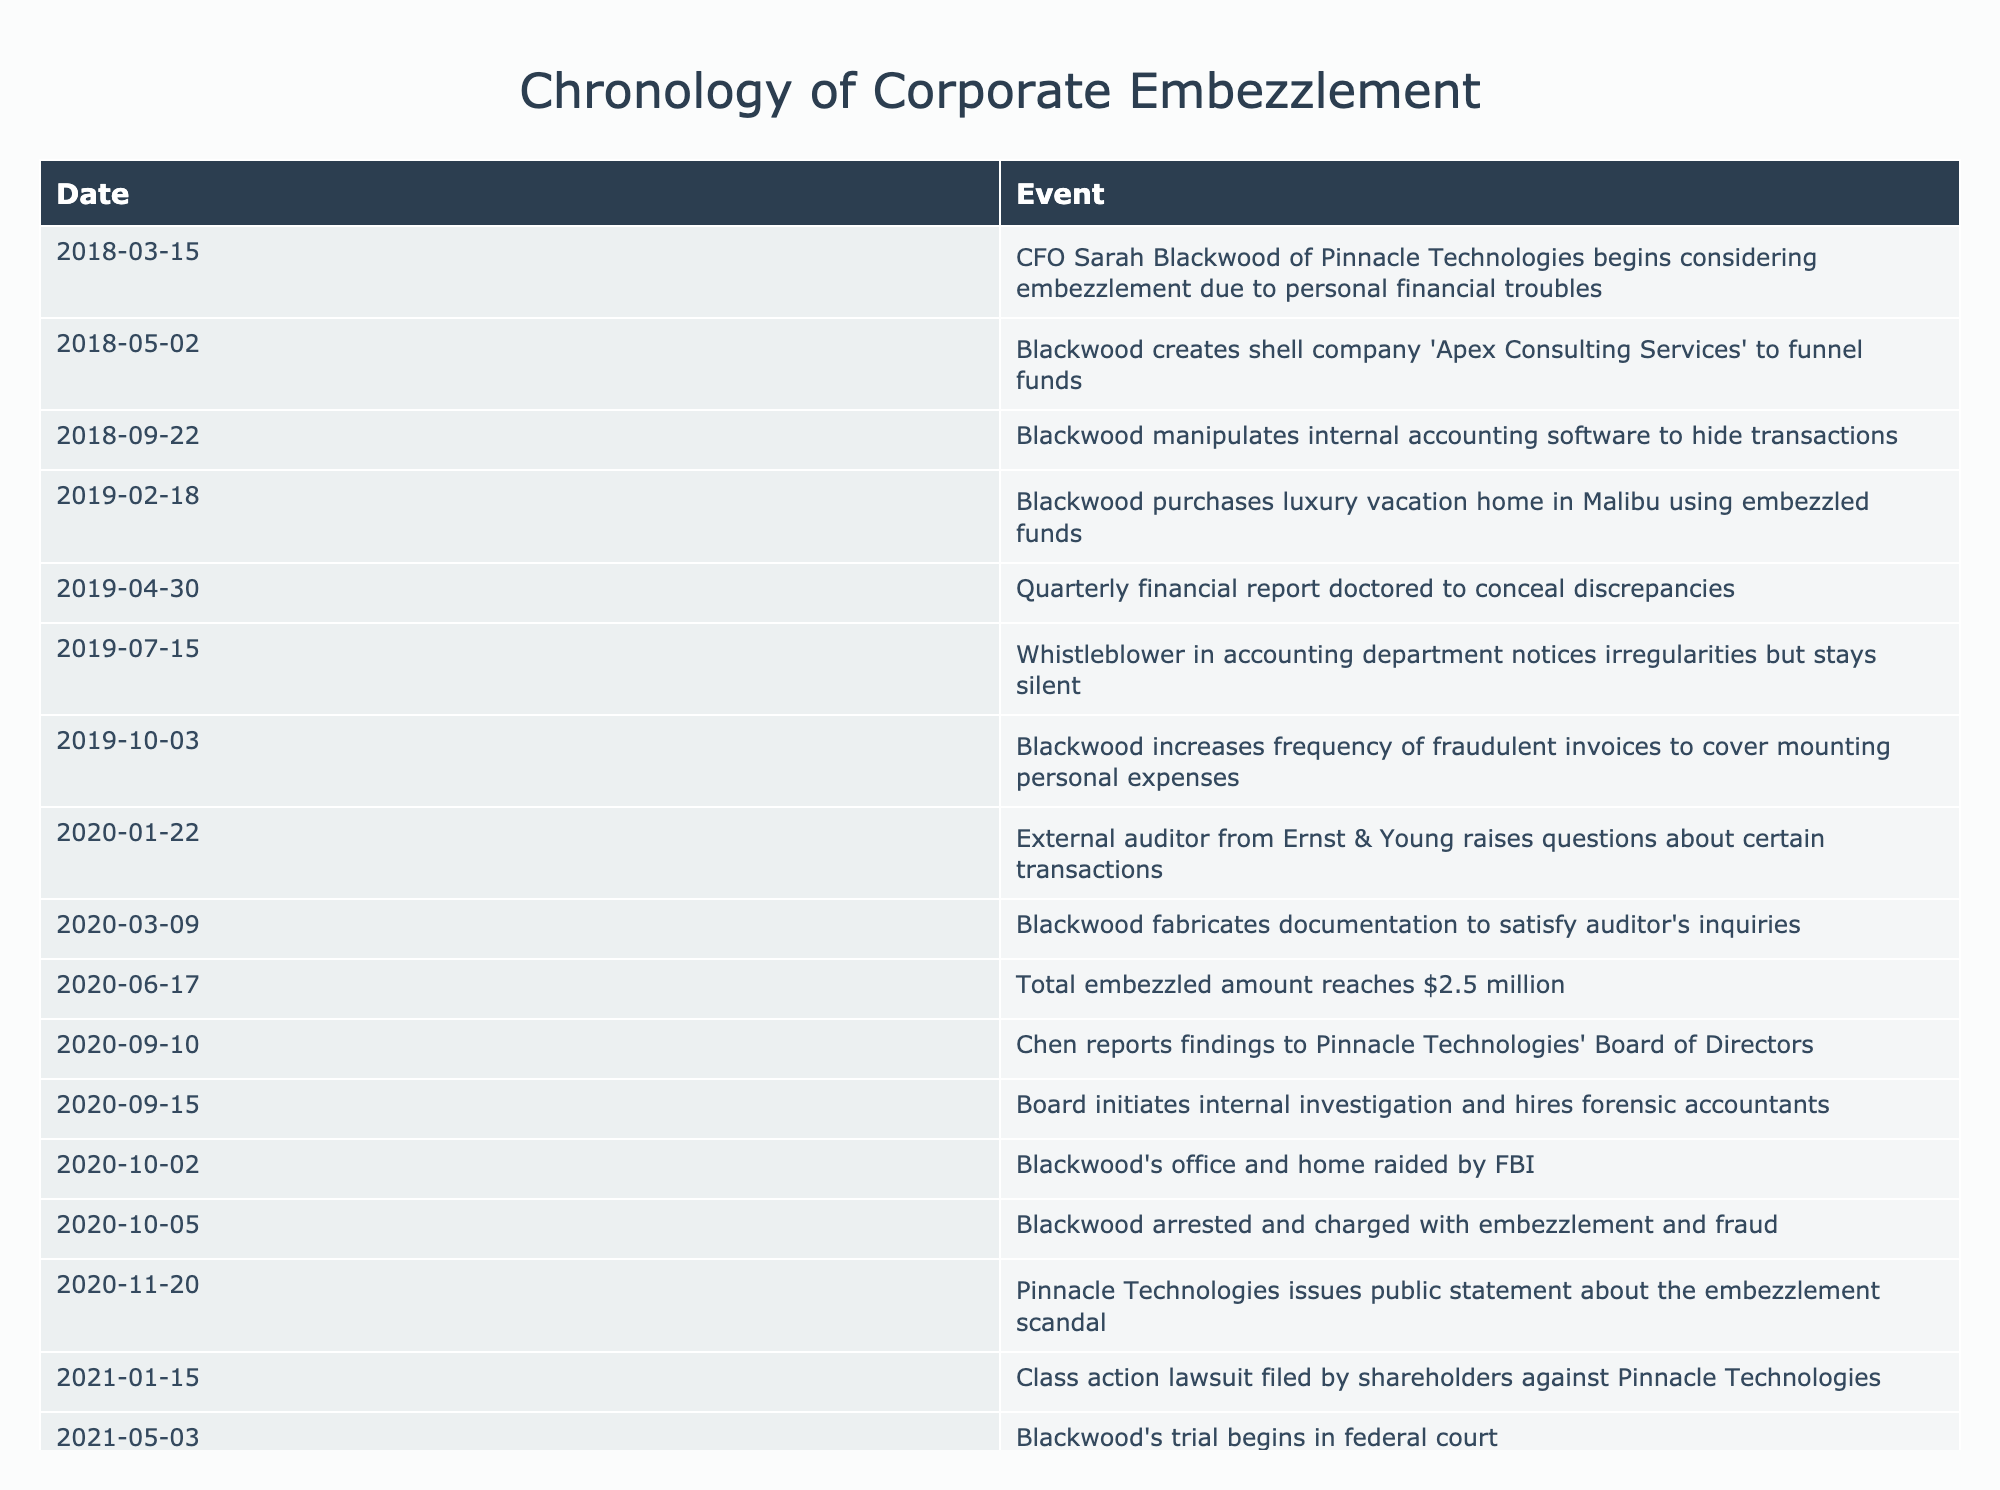What date did CFO Sarah Blackwood start considering embezzlement? From the table, we can see that the event stating "CFO Sarah Blackwood of Pinnacle Technologies begins considering embezzlement due to personal financial troubles" occurs on the date "2018-03-15."
Answer: 2018-03-15 How much money was embezzled by the time the total reached $2.5 million? The table shows that on "2020-06-17," the total embezzled amount reached $2.5 million. This is a direct retrieval from that row.
Answer: $2.5 million Was the external auditor from Ernst & Young the first to raise questions about transactions? Yes, according to the table, the external auditor raised questions on "2020-01-22," which is before any internal investigations were initiated by the Board.
Answer: Yes On which date was Blackwood arrested? The table states that Blackwood was arrested on "2020-10-05," providing a clear retrieval of that event.
Answer: 2020-10-05 What is the time interval between the creation of the shell company and Blackwood's arrest? Blackwood created the shell company "Apex Consulting Services" on "2018-05-02" and was arrested on "2020-10-05." The interval can be calculated as: October 5, 2020, minus May 2, 2018, which brings us 2 years, 5 months, and 3 days.
Answer: 2 years, 5 months, 3 days How many events took place after Blackwood purchased the luxury vacation home in Malibu? The luxury vacation home was purchased on "2019-02-18". From this date, the subsequent events are "Quarterly financial report doctored to conceal discrepancies" (2019-04-30), "Whistleblower in accounting department notices irregularities but stays silent" (2019-07-15), and so on, leading to a total of 7 events occurring after it. Counting the events listed after this date in the table provides this total.
Answer: 7 What evidence suggests that there were initial suspicions about embezzlement? The table includes an entry on "2019-07-15," where a whistleblower in the accounting department notices irregularities. This implies that there were already suspicions about fraudulent activities before the investigation began, as this event occurs before the auditor raised questions or the internal investigation started.
Answer: Yes How many months elapsed between the external auditor's inquiries and the initiation of the internal investigation? The external auditor raised questions on "2020-01-22" and the Board initiated the internal investigation on "2020-09-15." Counting these months, from January to September is 8 months. Therefore, the answer is obtained by identifying the time frame between the two dates.
Answer: 8 months 